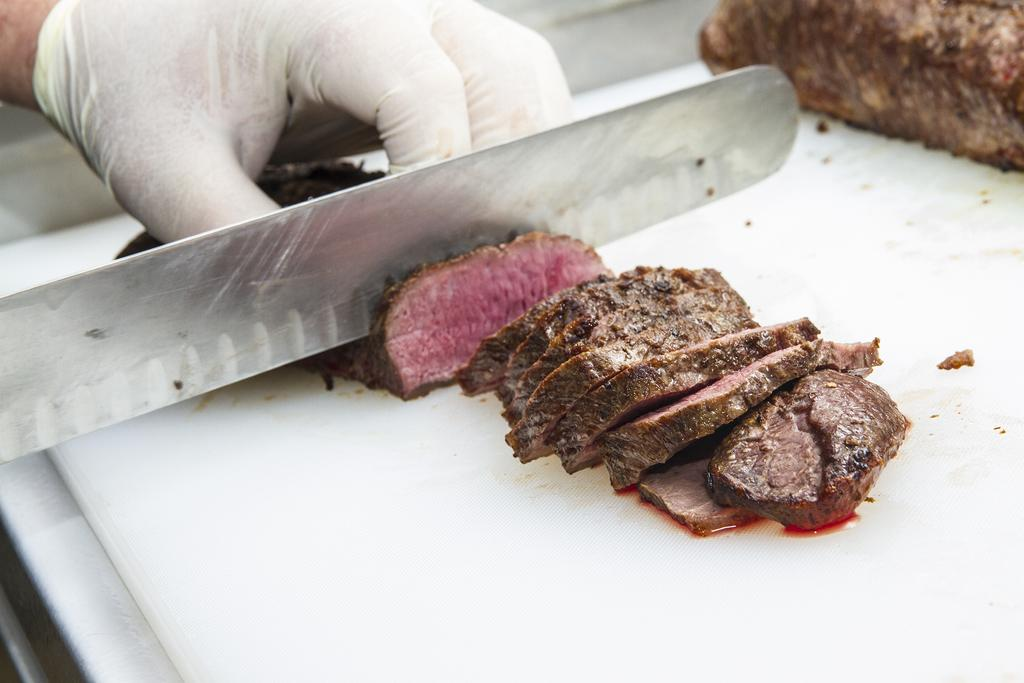What can be seen in the image related to a person's hand? There is a person's hand in the image, and it is wearing a glove. What is the hand doing in the image? The hand is cutting meat in the image. What is the surface on which the meat is being cut? The meat is being cut on a white surface in the image. What type of tin can be seen in the image? There is no tin present in the image. How does the baby contribute to the meat-cutting process in the image? There is no baby present in the image, so it cannot contribute to the meat-cutting process. 